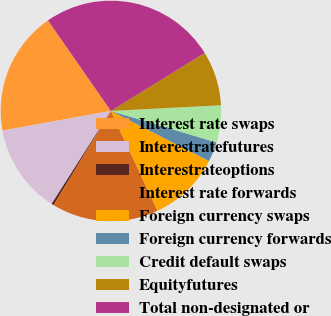Convert chart to OTSL. <chart><loc_0><loc_0><loc_500><loc_500><pie_chart><fcel>Interest rate swaps<fcel>Interestratefutures<fcel>Interestrateoptions<fcel>Interest rate forwards<fcel>Foreign currency swaps<fcel>Foreign currency forwards<fcel>Credit default swaps<fcel>Equityfutures<fcel>Total non-designated or<nl><fcel>18.2%<fcel>13.1%<fcel>0.34%<fcel>15.65%<fcel>10.54%<fcel>2.89%<fcel>5.44%<fcel>7.99%<fcel>25.86%<nl></chart> 